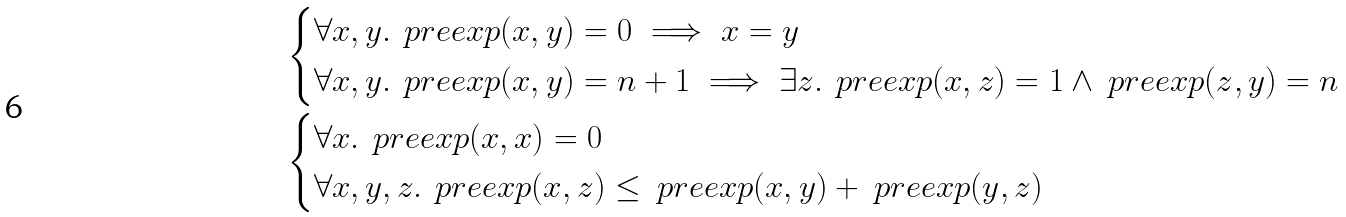<formula> <loc_0><loc_0><loc_500><loc_500>& \begin{cases} \forall x , y . \, \ p r e e x p ( x , y ) = 0 \implies x = y \\ \forall x , y . \, \ p r e e x p ( x , y ) = n + 1 \implies \exists z . \, \ p r e e x p ( x , z ) = 1 \land \ p r e e x p ( z , y ) = n \end{cases} \\ & \begin{cases} \forall x . \, \ p r e e x p ( x , x ) = 0 \\ \forall x , y , z . \, \ p r e e x p ( x , z ) \leq \ p r e e x p ( x , y ) + \ p r e e x p ( y , z ) \end{cases}</formula> 